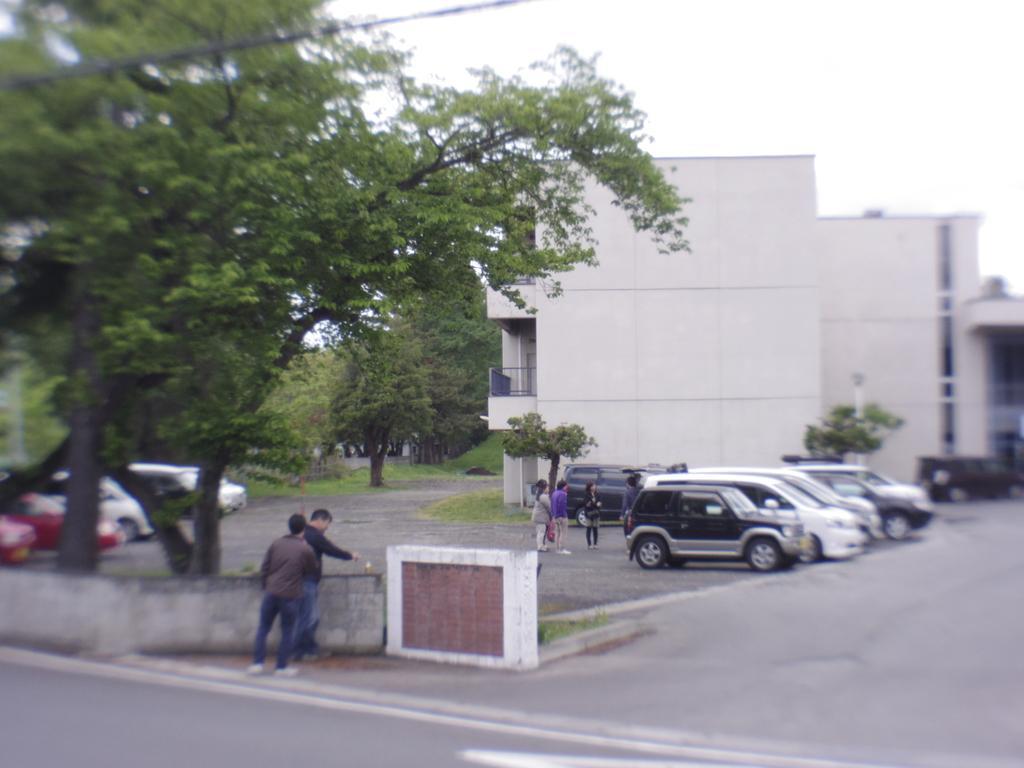Could you give a brief overview of what you see in this image? In this image, we can see cars and people standing on the road. In the background, there are trees, buildings. 